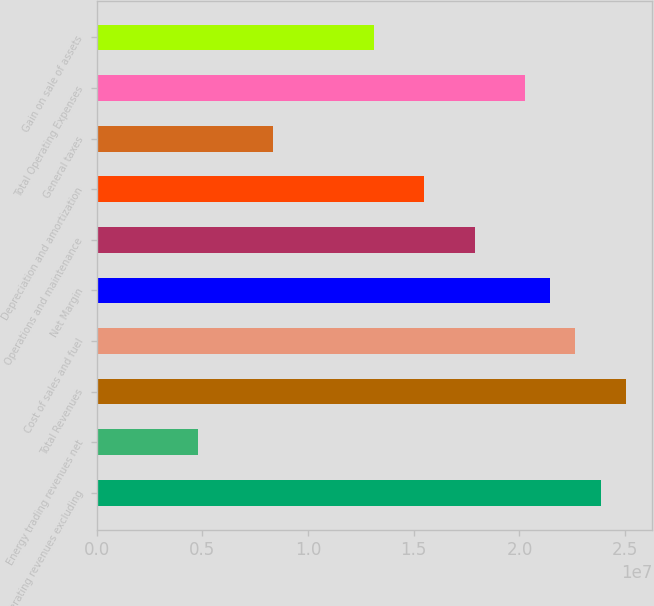<chart> <loc_0><loc_0><loc_500><loc_500><bar_chart><fcel>Operating revenues excluding<fcel>Energy trading revenues net<fcel>Total Revenues<fcel>Cost of sales and fuel<fcel>Net Margin<fcel>Operations and maintenance<fcel>Depreciation and amortization<fcel>General taxes<fcel>Total Operating Expenses<fcel>Gain on sale of assets<nl><fcel>2.38407e+07<fcel>4.76813e+06<fcel>2.50327e+07<fcel>2.26486e+07<fcel>2.14566e+07<fcel>1.78805e+07<fcel>1.54964e+07<fcel>8.34423e+06<fcel>2.02646e+07<fcel>1.31124e+07<nl></chart> 